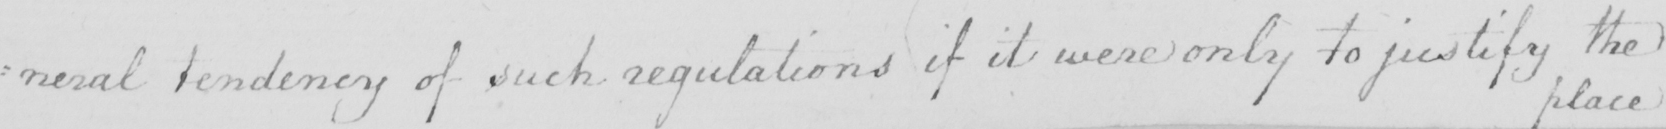Transcribe the text shown in this historical manuscript line. : neral tendency of such regulations if it were only to justify the 